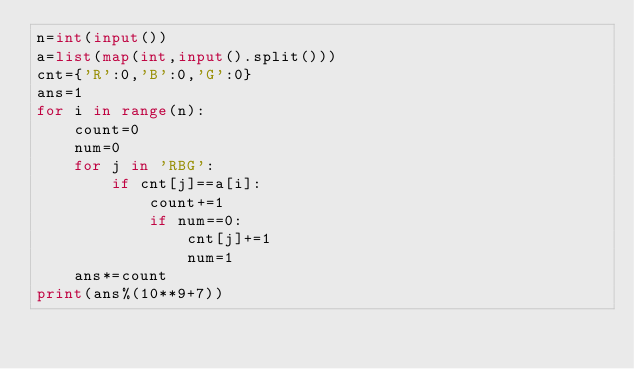Convert code to text. <code><loc_0><loc_0><loc_500><loc_500><_Python_>n=int(input())
a=list(map(int,input().split()))
cnt={'R':0,'B':0,'G':0}
ans=1
for i in range(n):
    count=0
    num=0
    for j in 'RBG':
        if cnt[j]==a[i]:
            count+=1
            if num==0:
                cnt[j]+=1
                num=1
    ans*=count
print(ans%(10**9+7))</code> 